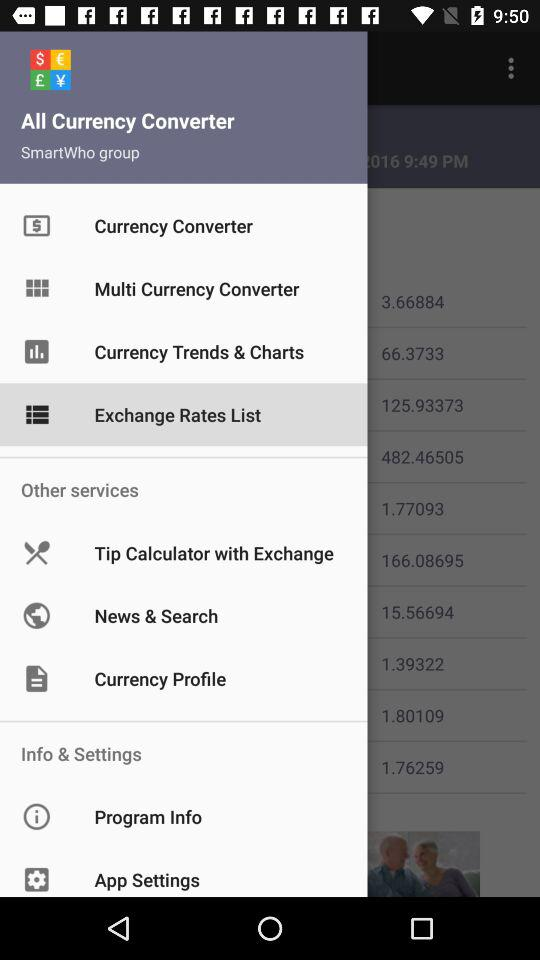Which option is selected? The selected option is "Exchange Rates List". 